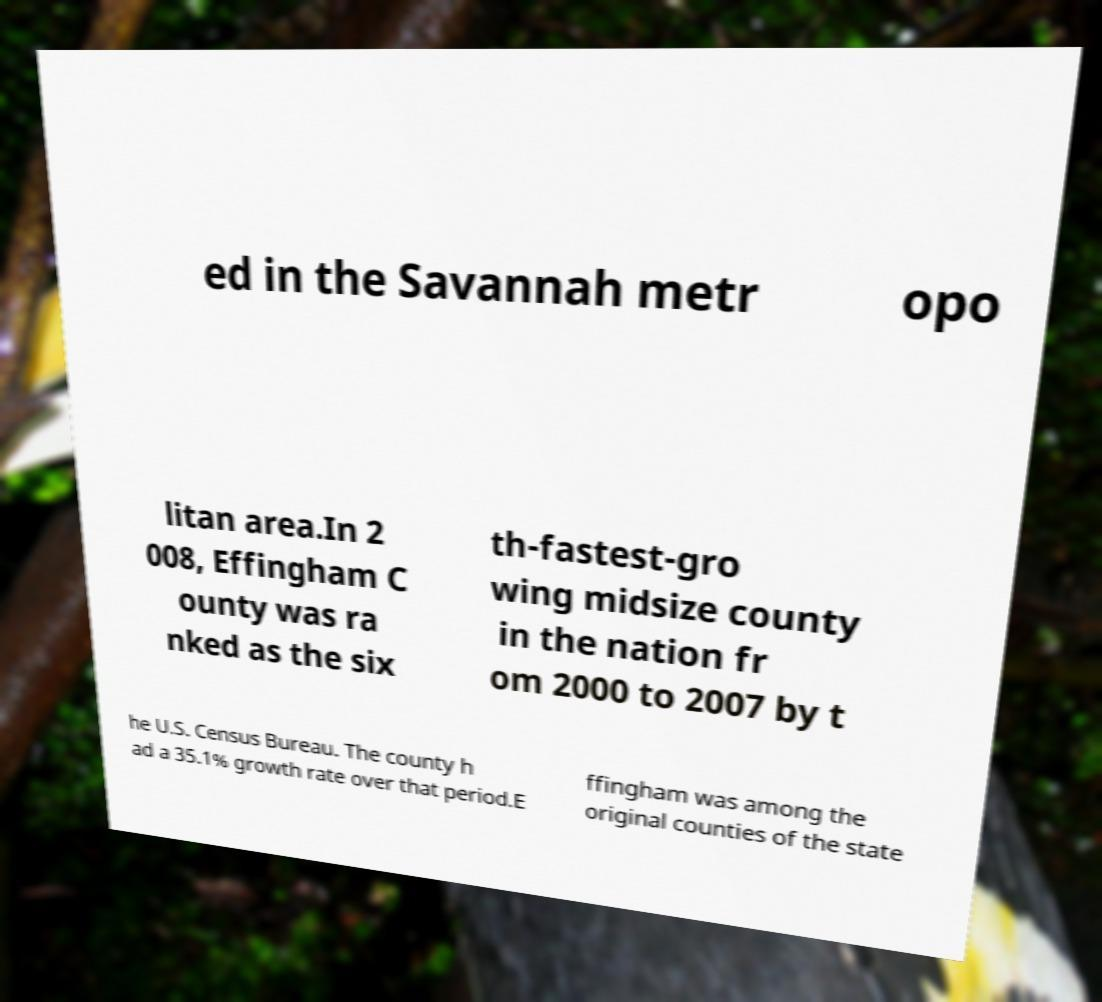Could you assist in decoding the text presented in this image and type it out clearly? ed in the Savannah metr opo litan area.In 2 008, Effingham C ounty was ra nked as the six th-fastest-gro wing midsize county in the nation fr om 2000 to 2007 by t he U.S. Census Bureau. The county h ad a 35.1% growth rate over that period.E ffingham was among the original counties of the state 